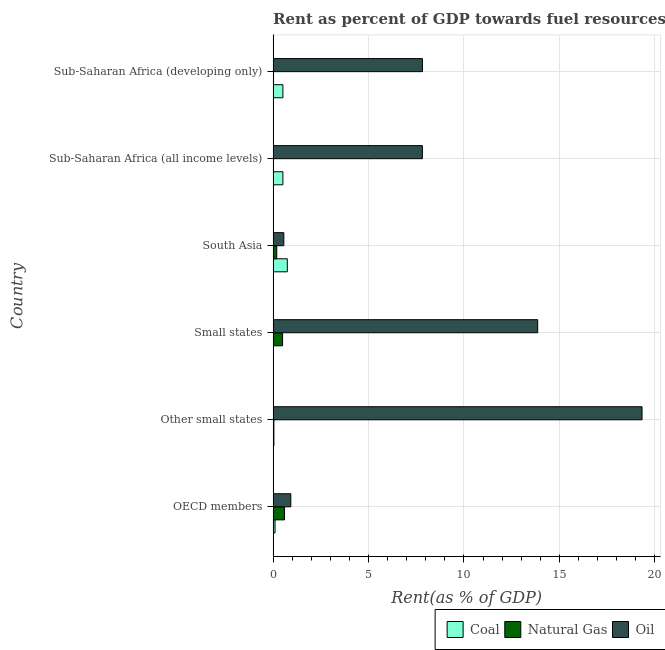How many different coloured bars are there?
Make the answer very short. 3. How many groups of bars are there?
Give a very brief answer. 6. Are the number of bars on each tick of the Y-axis equal?
Your response must be concise. Yes. How many bars are there on the 5th tick from the top?
Keep it short and to the point. 3. What is the label of the 5th group of bars from the top?
Provide a short and direct response. Other small states. In how many cases, is the number of bars for a given country not equal to the number of legend labels?
Your answer should be very brief. 0. What is the rent towards oil in Small states?
Make the answer very short. 13.86. Across all countries, what is the maximum rent towards natural gas?
Ensure brevity in your answer.  0.6. Across all countries, what is the minimum rent towards oil?
Ensure brevity in your answer.  0.56. In which country was the rent towards oil maximum?
Offer a very short reply. Other small states. In which country was the rent towards oil minimum?
Keep it short and to the point. South Asia. What is the total rent towards natural gas in the graph?
Offer a terse response. 1.37. What is the difference between the rent towards coal in South Asia and that in Sub-Saharan Africa (developing only)?
Provide a succinct answer. 0.23. What is the difference between the rent towards coal in Sub-Saharan Africa (all income levels) and the rent towards oil in Other small states?
Provide a short and direct response. -18.82. What is the average rent towards natural gas per country?
Your answer should be very brief. 0.23. What is the difference between the rent towards coal and rent towards natural gas in Sub-Saharan Africa (all income levels)?
Provide a succinct answer. 0.49. What is the ratio of the rent towards coal in OECD members to that in Sub-Saharan Africa (developing only)?
Keep it short and to the point. 0.2. What is the difference between the highest and the second highest rent towards oil?
Your response must be concise. 5.47. What is the difference between the highest and the lowest rent towards oil?
Your answer should be compact. 18.77. What does the 2nd bar from the top in OECD members represents?
Provide a short and direct response. Natural Gas. What does the 1st bar from the bottom in South Asia represents?
Your answer should be compact. Coal. Is it the case that in every country, the sum of the rent towards coal and rent towards natural gas is greater than the rent towards oil?
Ensure brevity in your answer.  No. How many bars are there?
Your response must be concise. 18. Are all the bars in the graph horizontal?
Keep it short and to the point. Yes. What is the title of the graph?
Ensure brevity in your answer.  Rent as percent of GDP towards fuel resources of different countries in 1976. Does "Spain" appear as one of the legend labels in the graph?
Offer a terse response. No. What is the label or title of the X-axis?
Offer a terse response. Rent(as % of GDP). What is the label or title of the Y-axis?
Offer a terse response. Country. What is the Rent(as % of GDP) of Coal in OECD members?
Provide a short and direct response. 0.1. What is the Rent(as % of GDP) of Natural Gas in OECD members?
Provide a short and direct response. 0.6. What is the Rent(as % of GDP) in Oil in OECD members?
Ensure brevity in your answer.  0.93. What is the Rent(as % of GDP) of Coal in Other small states?
Your response must be concise. 0.04. What is the Rent(as % of GDP) in Natural Gas in Other small states?
Your answer should be compact. 0.04. What is the Rent(as % of GDP) in Oil in Other small states?
Make the answer very short. 19.33. What is the Rent(as % of GDP) in Coal in Small states?
Provide a short and direct response. 0.02. What is the Rent(as % of GDP) in Natural Gas in Small states?
Provide a succinct answer. 0.49. What is the Rent(as % of GDP) in Oil in Small states?
Ensure brevity in your answer.  13.86. What is the Rent(as % of GDP) in Coal in South Asia?
Your response must be concise. 0.74. What is the Rent(as % of GDP) of Natural Gas in South Asia?
Offer a terse response. 0.19. What is the Rent(as % of GDP) of Oil in South Asia?
Your response must be concise. 0.56. What is the Rent(as % of GDP) of Coal in Sub-Saharan Africa (all income levels)?
Your response must be concise. 0.51. What is the Rent(as % of GDP) of Natural Gas in Sub-Saharan Africa (all income levels)?
Provide a short and direct response. 0.02. What is the Rent(as % of GDP) of Oil in Sub-Saharan Africa (all income levels)?
Offer a very short reply. 7.82. What is the Rent(as % of GDP) in Coal in Sub-Saharan Africa (developing only)?
Provide a short and direct response. 0.51. What is the Rent(as % of GDP) in Natural Gas in Sub-Saharan Africa (developing only)?
Your answer should be very brief. 0.02. What is the Rent(as % of GDP) in Oil in Sub-Saharan Africa (developing only)?
Provide a short and direct response. 7.83. Across all countries, what is the maximum Rent(as % of GDP) of Coal?
Your response must be concise. 0.74. Across all countries, what is the maximum Rent(as % of GDP) of Natural Gas?
Your answer should be compact. 0.6. Across all countries, what is the maximum Rent(as % of GDP) of Oil?
Keep it short and to the point. 19.33. Across all countries, what is the minimum Rent(as % of GDP) in Coal?
Provide a succinct answer. 0.02. Across all countries, what is the minimum Rent(as % of GDP) of Natural Gas?
Offer a terse response. 0.02. Across all countries, what is the minimum Rent(as % of GDP) in Oil?
Offer a very short reply. 0.56. What is the total Rent(as % of GDP) in Coal in the graph?
Offer a terse response. 1.93. What is the total Rent(as % of GDP) of Natural Gas in the graph?
Offer a terse response. 1.37. What is the total Rent(as % of GDP) of Oil in the graph?
Your answer should be very brief. 50.33. What is the difference between the Rent(as % of GDP) in Coal in OECD members and that in Other small states?
Make the answer very short. 0.06. What is the difference between the Rent(as % of GDP) of Natural Gas in OECD members and that in Other small states?
Your response must be concise. 0.56. What is the difference between the Rent(as % of GDP) in Oil in OECD members and that in Other small states?
Make the answer very short. -18.41. What is the difference between the Rent(as % of GDP) of Coal in OECD members and that in Small states?
Provide a short and direct response. 0.09. What is the difference between the Rent(as % of GDP) of Natural Gas in OECD members and that in Small states?
Your answer should be compact. 0.1. What is the difference between the Rent(as % of GDP) in Oil in OECD members and that in Small states?
Keep it short and to the point. -12.94. What is the difference between the Rent(as % of GDP) in Coal in OECD members and that in South Asia?
Your response must be concise. -0.64. What is the difference between the Rent(as % of GDP) in Natural Gas in OECD members and that in South Asia?
Your answer should be very brief. 0.41. What is the difference between the Rent(as % of GDP) of Oil in OECD members and that in South Asia?
Provide a succinct answer. 0.37. What is the difference between the Rent(as % of GDP) of Coal in OECD members and that in Sub-Saharan Africa (all income levels)?
Ensure brevity in your answer.  -0.41. What is the difference between the Rent(as % of GDP) in Natural Gas in OECD members and that in Sub-Saharan Africa (all income levels)?
Offer a very short reply. 0.58. What is the difference between the Rent(as % of GDP) in Oil in OECD members and that in Sub-Saharan Africa (all income levels)?
Provide a succinct answer. -6.9. What is the difference between the Rent(as % of GDP) of Coal in OECD members and that in Sub-Saharan Africa (developing only)?
Offer a very short reply. -0.41. What is the difference between the Rent(as % of GDP) of Natural Gas in OECD members and that in Sub-Saharan Africa (developing only)?
Ensure brevity in your answer.  0.58. What is the difference between the Rent(as % of GDP) of Oil in OECD members and that in Sub-Saharan Africa (developing only)?
Your answer should be compact. -6.9. What is the difference between the Rent(as % of GDP) of Coal in Other small states and that in Small states?
Provide a succinct answer. 0.03. What is the difference between the Rent(as % of GDP) of Natural Gas in Other small states and that in Small states?
Your response must be concise. -0.45. What is the difference between the Rent(as % of GDP) in Oil in Other small states and that in Small states?
Your answer should be compact. 5.47. What is the difference between the Rent(as % of GDP) of Coal in Other small states and that in South Asia?
Your answer should be very brief. -0.7. What is the difference between the Rent(as % of GDP) in Oil in Other small states and that in South Asia?
Offer a very short reply. 18.77. What is the difference between the Rent(as % of GDP) of Coal in Other small states and that in Sub-Saharan Africa (all income levels)?
Provide a short and direct response. -0.47. What is the difference between the Rent(as % of GDP) of Natural Gas in Other small states and that in Sub-Saharan Africa (all income levels)?
Your answer should be compact. 0.02. What is the difference between the Rent(as % of GDP) in Oil in Other small states and that in Sub-Saharan Africa (all income levels)?
Provide a short and direct response. 11.51. What is the difference between the Rent(as % of GDP) in Coal in Other small states and that in Sub-Saharan Africa (developing only)?
Offer a very short reply. -0.47. What is the difference between the Rent(as % of GDP) in Natural Gas in Other small states and that in Sub-Saharan Africa (developing only)?
Offer a very short reply. 0.02. What is the difference between the Rent(as % of GDP) of Oil in Other small states and that in Sub-Saharan Africa (developing only)?
Offer a very short reply. 11.51. What is the difference between the Rent(as % of GDP) in Coal in Small states and that in South Asia?
Make the answer very short. -0.73. What is the difference between the Rent(as % of GDP) in Natural Gas in Small states and that in South Asia?
Give a very brief answer. 0.3. What is the difference between the Rent(as % of GDP) in Oil in Small states and that in South Asia?
Your response must be concise. 13.3. What is the difference between the Rent(as % of GDP) of Coal in Small states and that in Sub-Saharan Africa (all income levels)?
Your response must be concise. -0.5. What is the difference between the Rent(as % of GDP) in Natural Gas in Small states and that in Sub-Saharan Africa (all income levels)?
Your response must be concise. 0.47. What is the difference between the Rent(as % of GDP) of Oil in Small states and that in Sub-Saharan Africa (all income levels)?
Provide a succinct answer. 6.04. What is the difference between the Rent(as % of GDP) in Coal in Small states and that in Sub-Saharan Africa (developing only)?
Give a very brief answer. -0.5. What is the difference between the Rent(as % of GDP) of Natural Gas in Small states and that in Sub-Saharan Africa (developing only)?
Keep it short and to the point. 0.47. What is the difference between the Rent(as % of GDP) in Oil in Small states and that in Sub-Saharan Africa (developing only)?
Provide a succinct answer. 6.04. What is the difference between the Rent(as % of GDP) in Coal in South Asia and that in Sub-Saharan Africa (all income levels)?
Make the answer very short. 0.23. What is the difference between the Rent(as % of GDP) in Natural Gas in South Asia and that in Sub-Saharan Africa (all income levels)?
Keep it short and to the point. 0.17. What is the difference between the Rent(as % of GDP) in Oil in South Asia and that in Sub-Saharan Africa (all income levels)?
Offer a very short reply. -7.26. What is the difference between the Rent(as % of GDP) in Coal in South Asia and that in Sub-Saharan Africa (developing only)?
Offer a very short reply. 0.23. What is the difference between the Rent(as % of GDP) in Natural Gas in South Asia and that in Sub-Saharan Africa (developing only)?
Provide a succinct answer. 0.17. What is the difference between the Rent(as % of GDP) of Oil in South Asia and that in Sub-Saharan Africa (developing only)?
Your answer should be compact. -7.26. What is the difference between the Rent(as % of GDP) of Coal in Sub-Saharan Africa (all income levels) and that in Sub-Saharan Africa (developing only)?
Give a very brief answer. -0. What is the difference between the Rent(as % of GDP) in Natural Gas in Sub-Saharan Africa (all income levels) and that in Sub-Saharan Africa (developing only)?
Make the answer very short. -0. What is the difference between the Rent(as % of GDP) of Oil in Sub-Saharan Africa (all income levels) and that in Sub-Saharan Africa (developing only)?
Ensure brevity in your answer.  -0. What is the difference between the Rent(as % of GDP) in Coal in OECD members and the Rent(as % of GDP) in Natural Gas in Other small states?
Provide a short and direct response. 0.06. What is the difference between the Rent(as % of GDP) in Coal in OECD members and the Rent(as % of GDP) in Oil in Other small states?
Make the answer very short. -19.23. What is the difference between the Rent(as % of GDP) in Natural Gas in OECD members and the Rent(as % of GDP) in Oil in Other small states?
Your answer should be very brief. -18.74. What is the difference between the Rent(as % of GDP) in Coal in OECD members and the Rent(as % of GDP) in Natural Gas in Small states?
Offer a very short reply. -0.39. What is the difference between the Rent(as % of GDP) in Coal in OECD members and the Rent(as % of GDP) in Oil in Small states?
Your answer should be compact. -13.76. What is the difference between the Rent(as % of GDP) in Natural Gas in OECD members and the Rent(as % of GDP) in Oil in Small states?
Your response must be concise. -13.27. What is the difference between the Rent(as % of GDP) in Coal in OECD members and the Rent(as % of GDP) in Natural Gas in South Asia?
Your answer should be compact. -0.09. What is the difference between the Rent(as % of GDP) in Coal in OECD members and the Rent(as % of GDP) in Oil in South Asia?
Keep it short and to the point. -0.46. What is the difference between the Rent(as % of GDP) of Natural Gas in OECD members and the Rent(as % of GDP) of Oil in South Asia?
Offer a very short reply. 0.04. What is the difference between the Rent(as % of GDP) in Coal in OECD members and the Rent(as % of GDP) in Natural Gas in Sub-Saharan Africa (all income levels)?
Provide a succinct answer. 0.08. What is the difference between the Rent(as % of GDP) of Coal in OECD members and the Rent(as % of GDP) of Oil in Sub-Saharan Africa (all income levels)?
Keep it short and to the point. -7.72. What is the difference between the Rent(as % of GDP) of Natural Gas in OECD members and the Rent(as % of GDP) of Oil in Sub-Saharan Africa (all income levels)?
Your response must be concise. -7.22. What is the difference between the Rent(as % of GDP) of Coal in OECD members and the Rent(as % of GDP) of Natural Gas in Sub-Saharan Africa (developing only)?
Keep it short and to the point. 0.08. What is the difference between the Rent(as % of GDP) of Coal in OECD members and the Rent(as % of GDP) of Oil in Sub-Saharan Africa (developing only)?
Give a very brief answer. -7.72. What is the difference between the Rent(as % of GDP) in Natural Gas in OECD members and the Rent(as % of GDP) in Oil in Sub-Saharan Africa (developing only)?
Your response must be concise. -7.23. What is the difference between the Rent(as % of GDP) in Coal in Other small states and the Rent(as % of GDP) in Natural Gas in Small states?
Make the answer very short. -0.45. What is the difference between the Rent(as % of GDP) in Coal in Other small states and the Rent(as % of GDP) in Oil in Small states?
Keep it short and to the point. -13.82. What is the difference between the Rent(as % of GDP) in Natural Gas in Other small states and the Rent(as % of GDP) in Oil in Small states?
Provide a succinct answer. -13.82. What is the difference between the Rent(as % of GDP) in Coal in Other small states and the Rent(as % of GDP) in Natural Gas in South Asia?
Provide a succinct answer. -0.15. What is the difference between the Rent(as % of GDP) of Coal in Other small states and the Rent(as % of GDP) of Oil in South Asia?
Provide a short and direct response. -0.52. What is the difference between the Rent(as % of GDP) in Natural Gas in Other small states and the Rent(as % of GDP) in Oil in South Asia?
Offer a very short reply. -0.52. What is the difference between the Rent(as % of GDP) of Coal in Other small states and the Rent(as % of GDP) of Natural Gas in Sub-Saharan Africa (all income levels)?
Your answer should be very brief. 0.02. What is the difference between the Rent(as % of GDP) in Coal in Other small states and the Rent(as % of GDP) in Oil in Sub-Saharan Africa (all income levels)?
Make the answer very short. -7.78. What is the difference between the Rent(as % of GDP) in Natural Gas in Other small states and the Rent(as % of GDP) in Oil in Sub-Saharan Africa (all income levels)?
Your answer should be compact. -7.78. What is the difference between the Rent(as % of GDP) in Coal in Other small states and the Rent(as % of GDP) in Natural Gas in Sub-Saharan Africa (developing only)?
Ensure brevity in your answer.  0.02. What is the difference between the Rent(as % of GDP) in Coal in Other small states and the Rent(as % of GDP) in Oil in Sub-Saharan Africa (developing only)?
Make the answer very short. -7.79. What is the difference between the Rent(as % of GDP) of Natural Gas in Other small states and the Rent(as % of GDP) of Oil in Sub-Saharan Africa (developing only)?
Give a very brief answer. -7.78. What is the difference between the Rent(as % of GDP) of Coal in Small states and the Rent(as % of GDP) of Natural Gas in South Asia?
Give a very brief answer. -0.18. What is the difference between the Rent(as % of GDP) in Coal in Small states and the Rent(as % of GDP) in Oil in South Asia?
Offer a terse response. -0.55. What is the difference between the Rent(as % of GDP) in Natural Gas in Small states and the Rent(as % of GDP) in Oil in South Asia?
Provide a short and direct response. -0.07. What is the difference between the Rent(as % of GDP) in Coal in Small states and the Rent(as % of GDP) in Natural Gas in Sub-Saharan Africa (all income levels)?
Provide a succinct answer. -0.01. What is the difference between the Rent(as % of GDP) in Coal in Small states and the Rent(as % of GDP) in Oil in Sub-Saharan Africa (all income levels)?
Ensure brevity in your answer.  -7.81. What is the difference between the Rent(as % of GDP) of Natural Gas in Small states and the Rent(as % of GDP) of Oil in Sub-Saharan Africa (all income levels)?
Your response must be concise. -7.33. What is the difference between the Rent(as % of GDP) of Coal in Small states and the Rent(as % of GDP) of Natural Gas in Sub-Saharan Africa (developing only)?
Offer a terse response. -0.01. What is the difference between the Rent(as % of GDP) of Coal in Small states and the Rent(as % of GDP) of Oil in Sub-Saharan Africa (developing only)?
Provide a succinct answer. -7.81. What is the difference between the Rent(as % of GDP) in Natural Gas in Small states and the Rent(as % of GDP) in Oil in Sub-Saharan Africa (developing only)?
Your answer should be compact. -7.33. What is the difference between the Rent(as % of GDP) of Coal in South Asia and the Rent(as % of GDP) of Natural Gas in Sub-Saharan Africa (all income levels)?
Make the answer very short. 0.72. What is the difference between the Rent(as % of GDP) in Coal in South Asia and the Rent(as % of GDP) in Oil in Sub-Saharan Africa (all income levels)?
Your answer should be very brief. -7.08. What is the difference between the Rent(as % of GDP) of Natural Gas in South Asia and the Rent(as % of GDP) of Oil in Sub-Saharan Africa (all income levels)?
Ensure brevity in your answer.  -7.63. What is the difference between the Rent(as % of GDP) of Coal in South Asia and the Rent(as % of GDP) of Natural Gas in Sub-Saharan Africa (developing only)?
Give a very brief answer. 0.72. What is the difference between the Rent(as % of GDP) in Coal in South Asia and the Rent(as % of GDP) in Oil in Sub-Saharan Africa (developing only)?
Give a very brief answer. -7.08. What is the difference between the Rent(as % of GDP) in Natural Gas in South Asia and the Rent(as % of GDP) in Oil in Sub-Saharan Africa (developing only)?
Your answer should be compact. -7.63. What is the difference between the Rent(as % of GDP) in Coal in Sub-Saharan Africa (all income levels) and the Rent(as % of GDP) in Natural Gas in Sub-Saharan Africa (developing only)?
Your answer should be compact. 0.49. What is the difference between the Rent(as % of GDP) in Coal in Sub-Saharan Africa (all income levels) and the Rent(as % of GDP) in Oil in Sub-Saharan Africa (developing only)?
Give a very brief answer. -7.31. What is the difference between the Rent(as % of GDP) in Natural Gas in Sub-Saharan Africa (all income levels) and the Rent(as % of GDP) in Oil in Sub-Saharan Africa (developing only)?
Keep it short and to the point. -7.8. What is the average Rent(as % of GDP) in Coal per country?
Offer a very short reply. 0.32. What is the average Rent(as % of GDP) of Natural Gas per country?
Offer a terse response. 0.23. What is the average Rent(as % of GDP) of Oil per country?
Provide a succinct answer. 8.39. What is the difference between the Rent(as % of GDP) in Coal and Rent(as % of GDP) in Natural Gas in OECD members?
Keep it short and to the point. -0.5. What is the difference between the Rent(as % of GDP) in Coal and Rent(as % of GDP) in Oil in OECD members?
Keep it short and to the point. -0.83. What is the difference between the Rent(as % of GDP) of Natural Gas and Rent(as % of GDP) of Oil in OECD members?
Your answer should be compact. -0.33. What is the difference between the Rent(as % of GDP) of Coal and Rent(as % of GDP) of Natural Gas in Other small states?
Your answer should be compact. -0. What is the difference between the Rent(as % of GDP) in Coal and Rent(as % of GDP) in Oil in Other small states?
Your answer should be compact. -19.29. What is the difference between the Rent(as % of GDP) in Natural Gas and Rent(as % of GDP) in Oil in Other small states?
Your answer should be compact. -19.29. What is the difference between the Rent(as % of GDP) in Coal and Rent(as % of GDP) in Natural Gas in Small states?
Offer a very short reply. -0.48. What is the difference between the Rent(as % of GDP) of Coal and Rent(as % of GDP) of Oil in Small states?
Provide a short and direct response. -13.85. What is the difference between the Rent(as % of GDP) of Natural Gas and Rent(as % of GDP) of Oil in Small states?
Offer a terse response. -13.37. What is the difference between the Rent(as % of GDP) in Coal and Rent(as % of GDP) in Natural Gas in South Asia?
Keep it short and to the point. 0.55. What is the difference between the Rent(as % of GDP) in Coal and Rent(as % of GDP) in Oil in South Asia?
Keep it short and to the point. 0.18. What is the difference between the Rent(as % of GDP) in Natural Gas and Rent(as % of GDP) in Oil in South Asia?
Keep it short and to the point. -0.37. What is the difference between the Rent(as % of GDP) in Coal and Rent(as % of GDP) in Natural Gas in Sub-Saharan Africa (all income levels)?
Your response must be concise. 0.49. What is the difference between the Rent(as % of GDP) in Coal and Rent(as % of GDP) in Oil in Sub-Saharan Africa (all income levels)?
Make the answer very short. -7.31. What is the difference between the Rent(as % of GDP) in Natural Gas and Rent(as % of GDP) in Oil in Sub-Saharan Africa (all income levels)?
Offer a terse response. -7.8. What is the difference between the Rent(as % of GDP) of Coal and Rent(as % of GDP) of Natural Gas in Sub-Saharan Africa (developing only)?
Give a very brief answer. 0.49. What is the difference between the Rent(as % of GDP) of Coal and Rent(as % of GDP) of Oil in Sub-Saharan Africa (developing only)?
Offer a very short reply. -7.31. What is the difference between the Rent(as % of GDP) in Natural Gas and Rent(as % of GDP) in Oil in Sub-Saharan Africa (developing only)?
Offer a terse response. -7.8. What is the ratio of the Rent(as % of GDP) of Coal in OECD members to that in Other small states?
Provide a succinct answer. 2.51. What is the ratio of the Rent(as % of GDP) of Natural Gas in OECD members to that in Other small states?
Provide a succinct answer. 14.74. What is the ratio of the Rent(as % of GDP) in Oil in OECD members to that in Other small states?
Your answer should be very brief. 0.05. What is the ratio of the Rent(as % of GDP) in Coal in OECD members to that in Small states?
Provide a succinct answer. 6.66. What is the ratio of the Rent(as % of GDP) of Natural Gas in OECD members to that in Small states?
Provide a short and direct response. 1.21. What is the ratio of the Rent(as % of GDP) in Oil in OECD members to that in Small states?
Your response must be concise. 0.07. What is the ratio of the Rent(as % of GDP) of Coal in OECD members to that in South Asia?
Your answer should be very brief. 0.14. What is the ratio of the Rent(as % of GDP) of Natural Gas in OECD members to that in South Asia?
Provide a succinct answer. 3.14. What is the ratio of the Rent(as % of GDP) in Oil in OECD members to that in South Asia?
Offer a very short reply. 1.65. What is the ratio of the Rent(as % of GDP) of Coal in OECD members to that in Sub-Saharan Africa (all income levels)?
Keep it short and to the point. 0.2. What is the ratio of the Rent(as % of GDP) in Natural Gas in OECD members to that in Sub-Saharan Africa (all income levels)?
Your answer should be compact. 27.28. What is the ratio of the Rent(as % of GDP) of Oil in OECD members to that in Sub-Saharan Africa (all income levels)?
Offer a terse response. 0.12. What is the ratio of the Rent(as % of GDP) in Coal in OECD members to that in Sub-Saharan Africa (developing only)?
Give a very brief answer. 0.2. What is the ratio of the Rent(as % of GDP) in Natural Gas in OECD members to that in Sub-Saharan Africa (developing only)?
Offer a terse response. 27.25. What is the ratio of the Rent(as % of GDP) in Oil in OECD members to that in Sub-Saharan Africa (developing only)?
Provide a succinct answer. 0.12. What is the ratio of the Rent(as % of GDP) of Coal in Other small states to that in Small states?
Offer a very short reply. 2.65. What is the ratio of the Rent(as % of GDP) of Natural Gas in Other small states to that in Small states?
Ensure brevity in your answer.  0.08. What is the ratio of the Rent(as % of GDP) of Oil in Other small states to that in Small states?
Your answer should be compact. 1.39. What is the ratio of the Rent(as % of GDP) in Coal in Other small states to that in South Asia?
Offer a terse response. 0.05. What is the ratio of the Rent(as % of GDP) of Natural Gas in Other small states to that in South Asia?
Your answer should be very brief. 0.21. What is the ratio of the Rent(as % of GDP) in Oil in Other small states to that in South Asia?
Ensure brevity in your answer.  34.48. What is the ratio of the Rent(as % of GDP) in Coal in Other small states to that in Sub-Saharan Africa (all income levels)?
Give a very brief answer. 0.08. What is the ratio of the Rent(as % of GDP) in Natural Gas in Other small states to that in Sub-Saharan Africa (all income levels)?
Your answer should be compact. 1.85. What is the ratio of the Rent(as % of GDP) of Oil in Other small states to that in Sub-Saharan Africa (all income levels)?
Ensure brevity in your answer.  2.47. What is the ratio of the Rent(as % of GDP) of Coal in Other small states to that in Sub-Saharan Africa (developing only)?
Offer a very short reply. 0.08. What is the ratio of the Rent(as % of GDP) in Natural Gas in Other small states to that in Sub-Saharan Africa (developing only)?
Offer a very short reply. 1.85. What is the ratio of the Rent(as % of GDP) in Oil in Other small states to that in Sub-Saharan Africa (developing only)?
Keep it short and to the point. 2.47. What is the ratio of the Rent(as % of GDP) of Coal in Small states to that in South Asia?
Your answer should be compact. 0.02. What is the ratio of the Rent(as % of GDP) in Natural Gas in Small states to that in South Asia?
Make the answer very short. 2.6. What is the ratio of the Rent(as % of GDP) of Oil in Small states to that in South Asia?
Your response must be concise. 24.73. What is the ratio of the Rent(as % of GDP) of Coal in Small states to that in Sub-Saharan Africa (all income levels)?
Ensure brevity in your answer.  0.03. What is the ratio of the Rent(as % of GDP) of Natural Gas in Small states to that in Sub-Saharan Africa (all income levels)?
Your answer should be very brief. 22.58. What is the ratio of the Rent(as % of GDP) of Oil in Small states to that in Sub-Saharan Africa (all income levels)?
Offer a very short reply. 1.77. What is the ratio of the Rent(as % of GDP) in Coal in Small states to that in Sub-Saharan Africa (developing only)?
Your response must be concise. 0.03. What is the ratio of the Rent(as % of GDP) in Natural Gas in Small states to that in Sub-Saharan Africa (developing only)?
Offer a very short reply. 22.55. What is the ratio of the Rent(as % of GDP) in Oil in Small states to that in Sub-Saharan Africa (developing only)?
Make the answer very short. 1.77. What is the ratio of the Rent(as % of GDP) of Coal in South Asia to that in Sub-Saharan Africa (all income levels)?
Keep it short and to the point. 1.45. What is the ratio of the Rent(as % of GDP) in Natural Gas in South Asia to that in Sub-Saharan Africa (all income levels)?
Make the answer very short. 8.7. What is the ratio of the Rent(as % of GDP) in Oil in South Asia to that in Sub-Saharan Africa (all income levels)?
Ensure brevity in your answer.  0.07. What is the ratio of the Rent(as % of GDP) in Coal in South Asia to that in Sub-Saharan Africa (developing only)?
Provide a succinct answer. 1.45. What is the ratio of the Rent(as % of GDP) in Natural Gas in South Asia to that in Sub-Saharan Africa (developing only)?
Offer a very short reply. 8.69. What is the ratio of the Rent(as % of GDP) in Oil in South Asia to that in Sub-Saharan Africa (developing only)?
Your answer should be compact. 0.07. What is the ratio of the Rent(as % of GDP) in Coal in Sub-Saharan Africa (all income levels) to that in Sub-Saharan Africa (developing only)?
Your response must be concise. 1. What is the difference between the highest and the second highest Rent(as % of GDP) in Coal?
Keep it short and to the point. 0.23. What is the difference between the highest and the second highest Rent(as % of GDP) of Natural Gas?
Your response must be concise. 0.1. What is the difference between the highest and the second highest Rent(as % of GDP) in Oil?
Ensure brevity in your answer.  5.47. What is the difference between the highest and the lowest Rent(as % of GDP) of Coal?
Make the answer very short. 0.73. What is the difference between the highest and the lowest Rent(as % of GDP) of Natural Gas?
Provide a succinct answer. 0.58. What is the difference between the highest and the lowest Rent(as % of GDP) in Oil?
Your response must be concise. 18.77. 